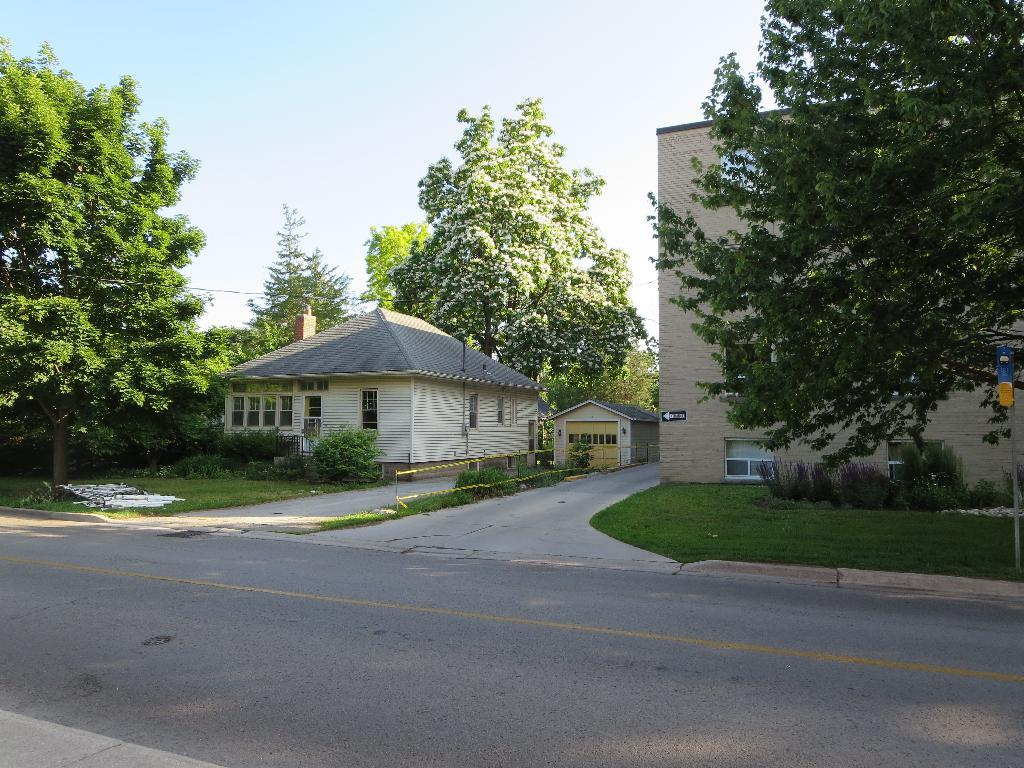What type of structures can be seen in the image? There are buildings in the image. What is the main feature of the landscape in the image? There is a road in the image. What type of vegetation is present in the image? There are trees and plants in the image. What is the ground covered with in the image? There is grass on the ground in the image. What is visible at the top of the image? The sky is visible at the top of the image. Can you tell me how many owls are perched on the trees in the image? There are no owls present in the image; it features buildings, a road, trees, plants, grass, and the sky. Is there a kite flying in the sky in the image? There is no kite visible in the sky in the image. 